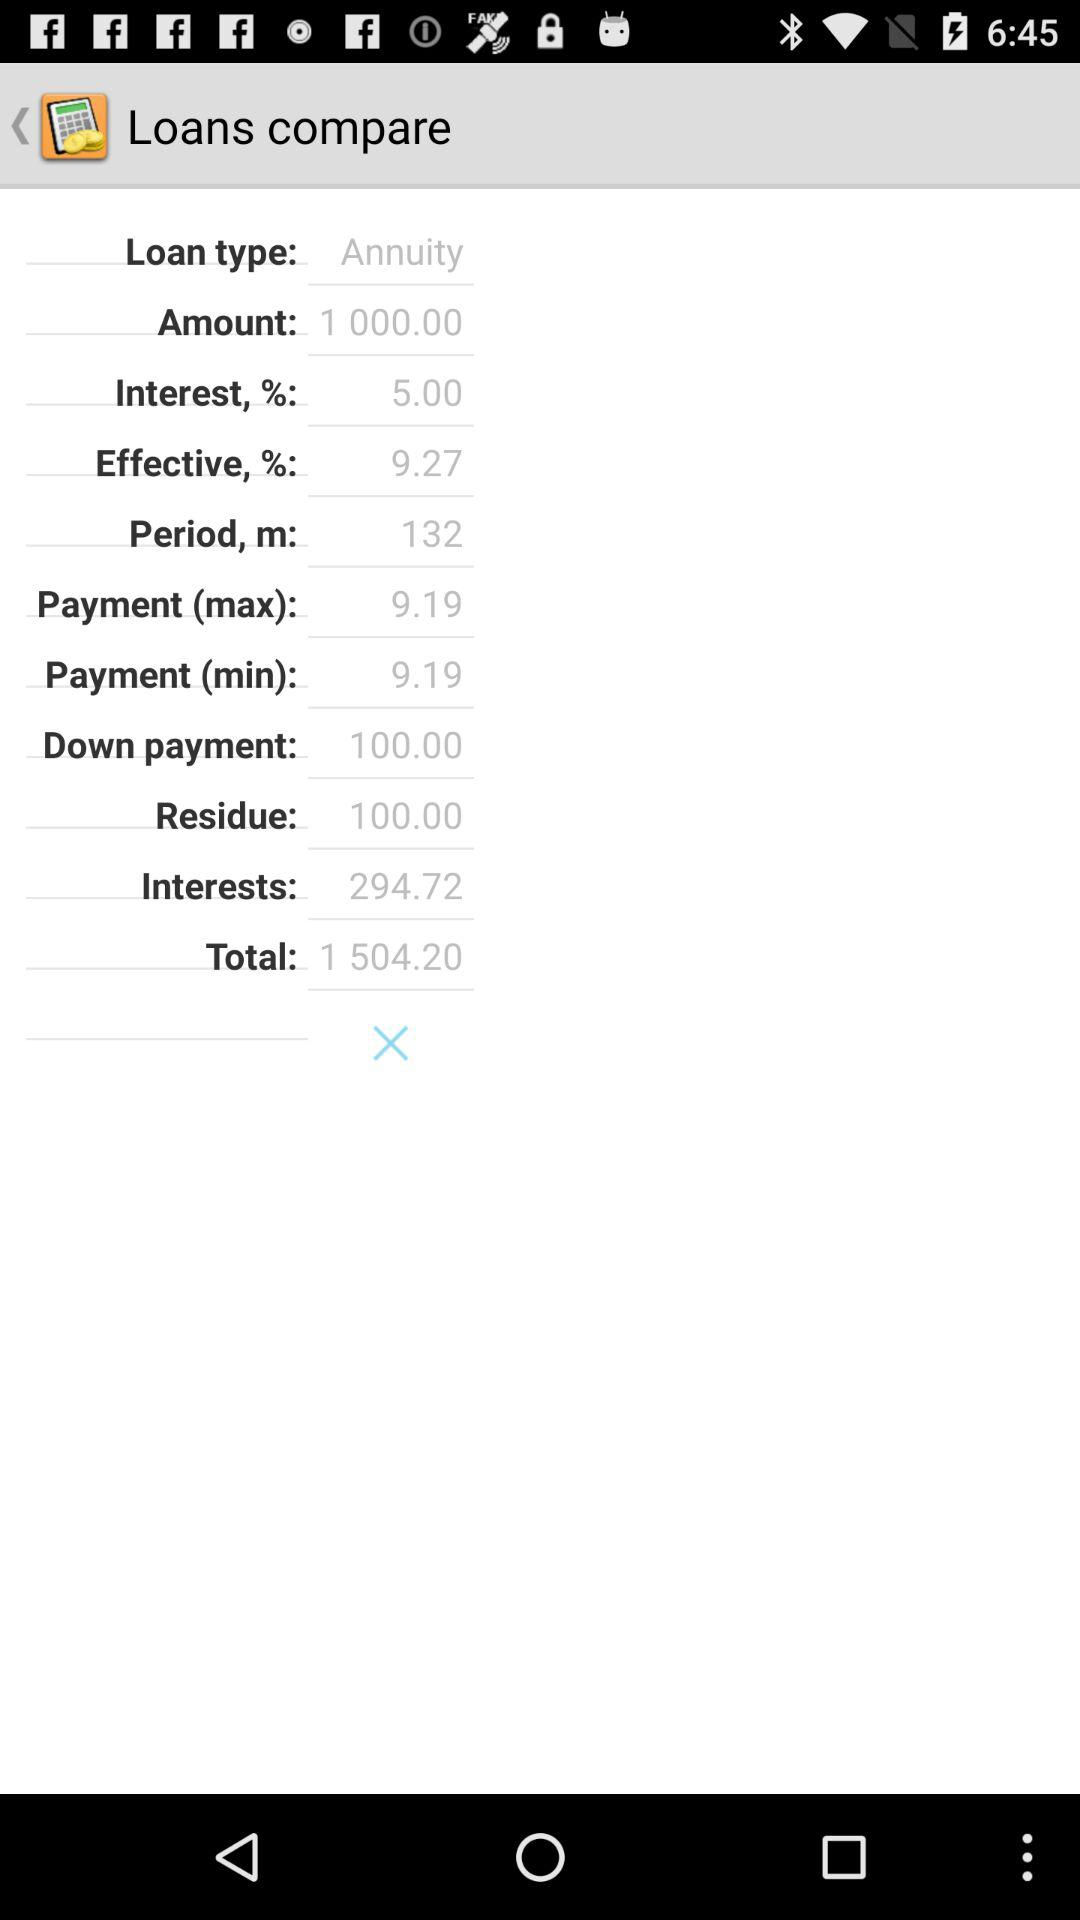How much is the total interest paid over the life of the loan?
Answer the question using a single word or phrase. 294.72 